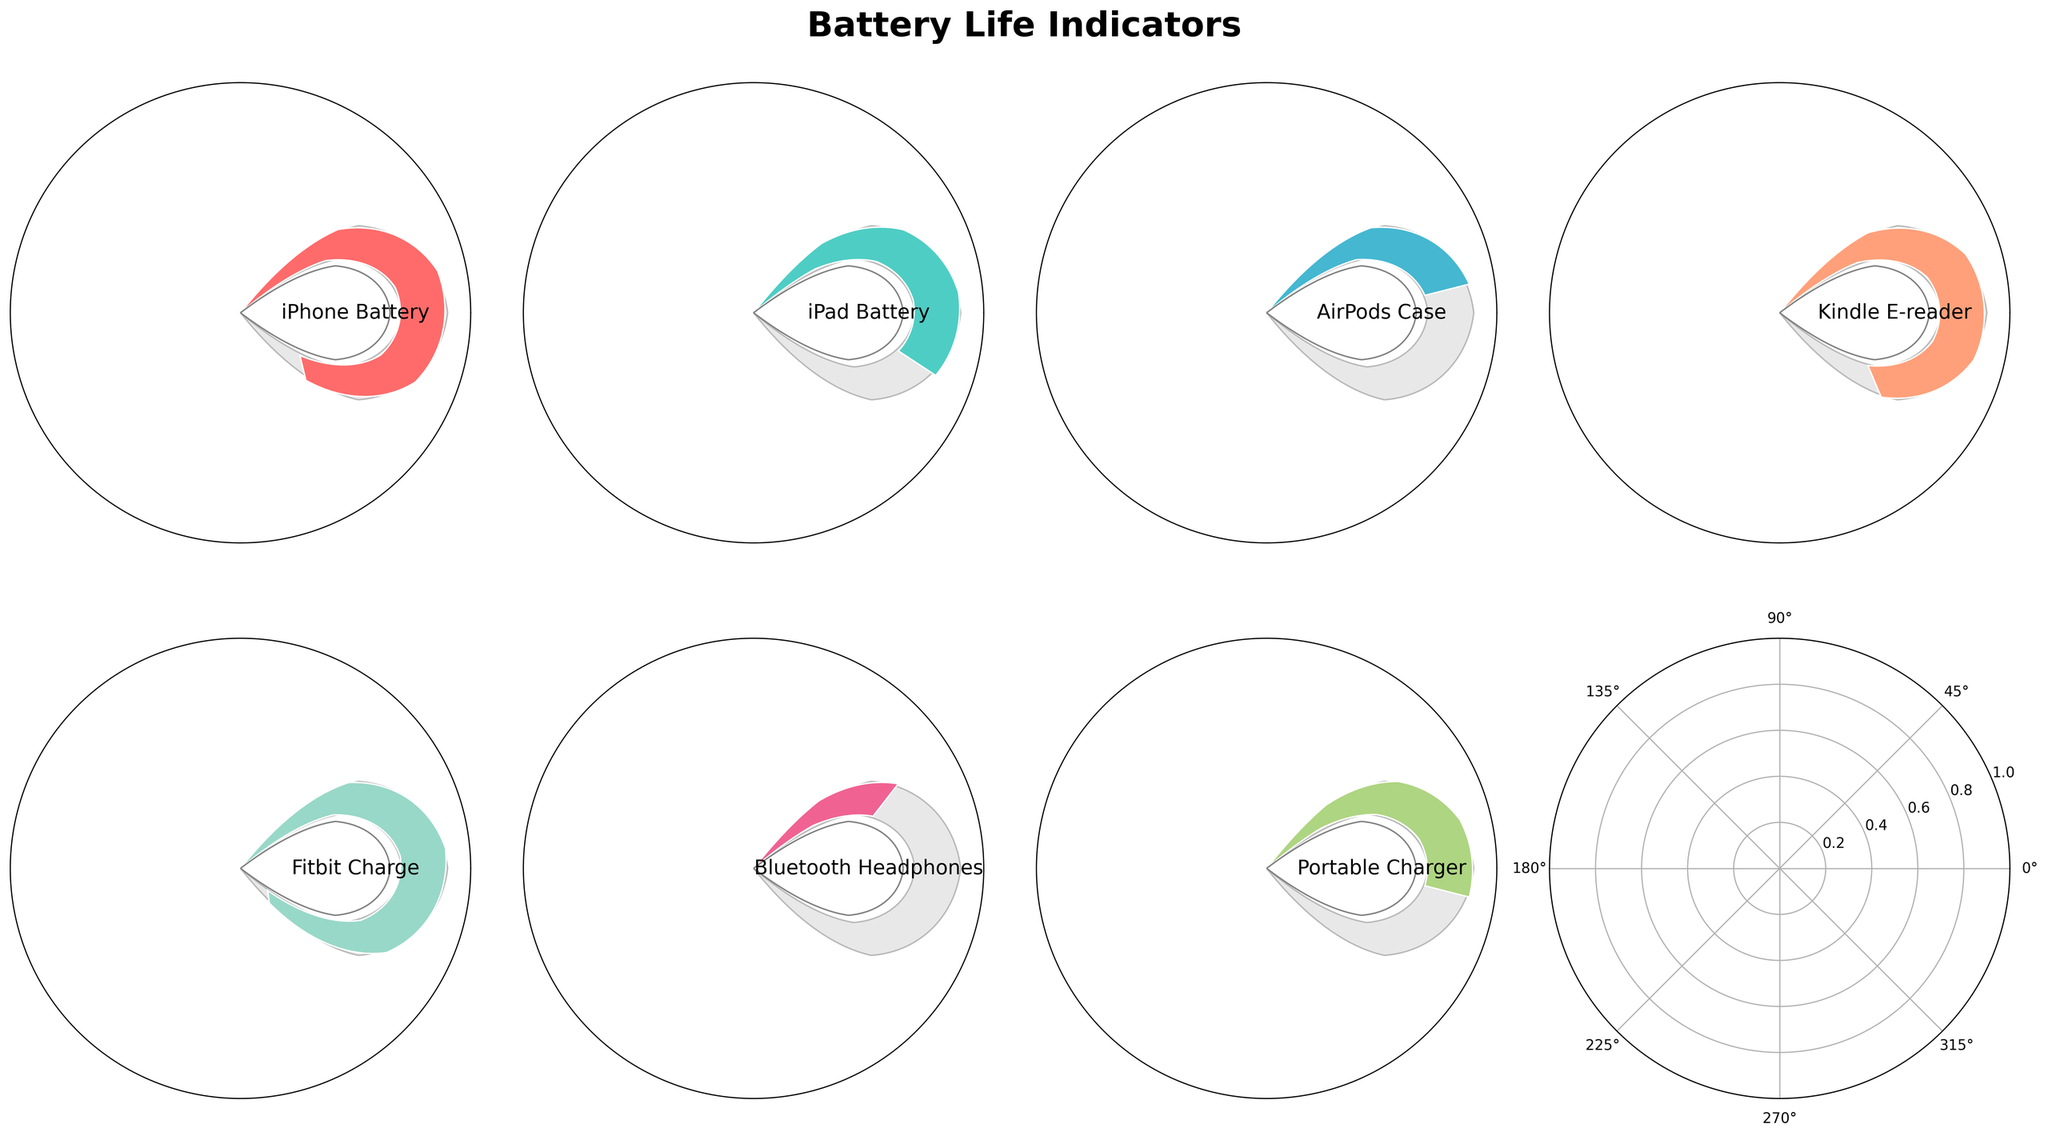What's the title of the figure? The title is displayed at the top center of the figure. It reads "Battery Life Indicators".
Answer: Battery Life Indicators How many battery indicators are displayed in the figure? The plot contains 7 indicators for different personal electronic devices as indicated by the labels on the plots: iPhone, iPad, AirPods Case, Kindle E-reader, Fitbit Charge, Bluetooth Headphones, and Portable Charger.
Answer: 7 Which device has the highest battery life? By observing the value texts inside the indicators, the highest battery life is for the "Fitbit Charge" with a value of 93%.
Answer: Fitbit Charge What is the average battery life of all the displayed devices? The battery values are 85, 62, 45, 78, 93, 30, and 55. Sum them up to get 448, and then divide by the number of devices (7). Thus, the average battery life is 448 / 7 = 64%.
Answer: 64% Which devices have a battery life of less than 50%? By noting the battery values, the devices with less than 50% battery life are the "AirPods Case" (45%) and "Bluetooth Headphones" (30%).
Answer: AirPods Case, Bluetooth Headphones What's the difference in battery life between the iPhone and the iPad? The battery life of the iPhone is 85%, and that of the iPad is 62%. Their difference is 85% - 62% = 23%.
Answer: 23% What is the median battery life value of the devices? The sorted battery life values are 30, 45, 55, 62, 78, 85, 93. With 7 devices, the median is the middle value, which is the 4th value (62%).
Answer: 62% Which device has the smallest battery life? By looking at the value texts, the smallest battery life is for "Bluetooth Headphones" at 30%.
Answer: Bluetooth Headphones How many devices have a battery life greater than or equal to 75%? The devices with battery life values of 85, 78, and 93 are considered. By counting them, we find there are 3 such devices.
Answer: 3 